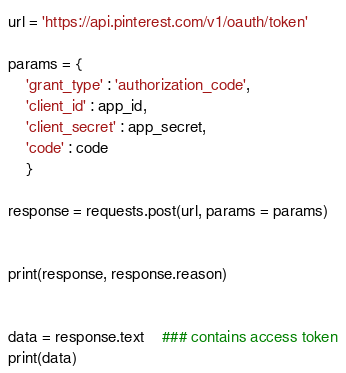<code> <loc_0><loc_0><loc_500><loc_500><_Python_>url = 'https://api.pinterest.com/v1/oauth/token'

params = {
    'grant_type' : 'authorization_code',
    'client_id' : app_id,
    'client_secret' : app_secret,
    'code' : code
    }

response = requests.post(url, params = params)


print(response, response.reason)


data = response.text	### contains access token
print(data)
</code> 